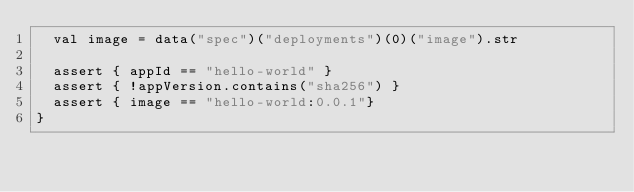<code> <loc_0><loc_0><loc_500><loc_500><_Scala_>  val image = data("spec")("deployments")(0)("image").str

  assert { appId == "hello-world" }
  assert { !appVersion.contains("sha256") }
  assert { image == "hello-world:0.0.1"}
}
</code> 